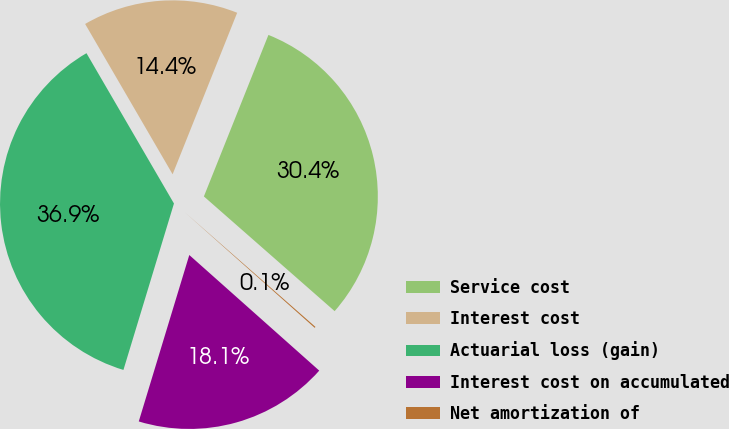Convert chart to OTSL. <chart><loc_0><loc_0><loc_500><loc_500><pie_chart><fcel>Service cost<fcel>Interest cost<fcel>Actuarial loss (gain)<fcel>Interest cost on accumulated<fcel>Net amortization of<nl><fcel>30.41%<fcel>14.44%<fcel>36.92%<fcel>18.12%<fcel>0.11%<nl></chart> 